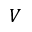<formula> <loc_0><loc_0><loc_500><loc_500>V</formula> 